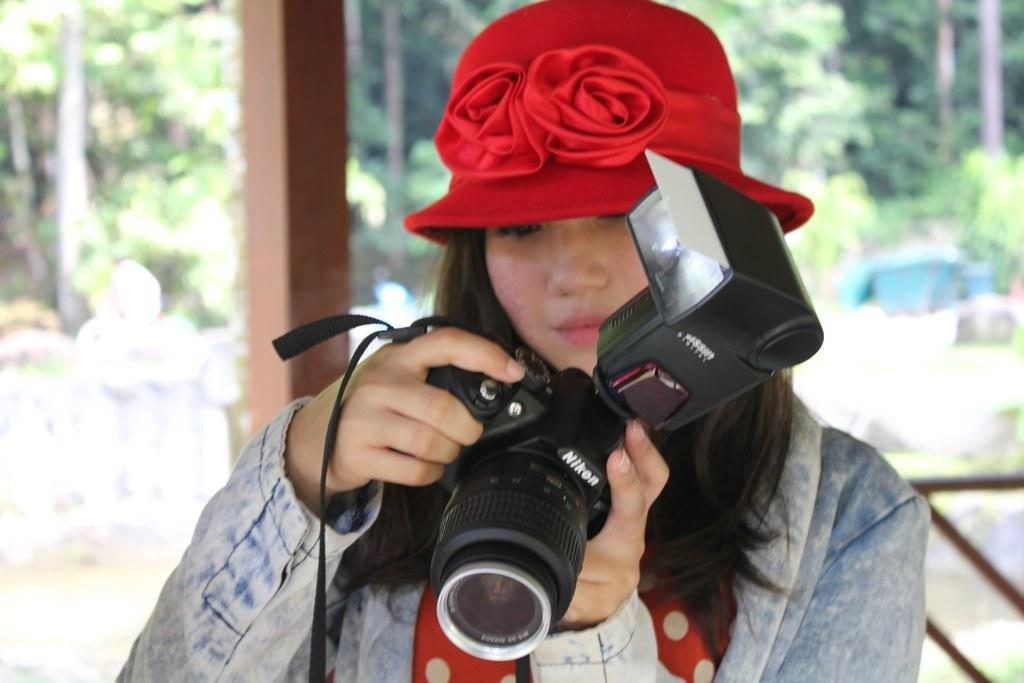Who is the main subject in the image? There is a woman in the image. What is the woman holding in her hands? The woman is holding a camera with her hands. What can be seen in the background of the image? There are trees in the background of the image. What idea does the woman have for her next wish in the image? There is no mention of wishes or ideas in the image; it simply shows a woman holding a camera. 